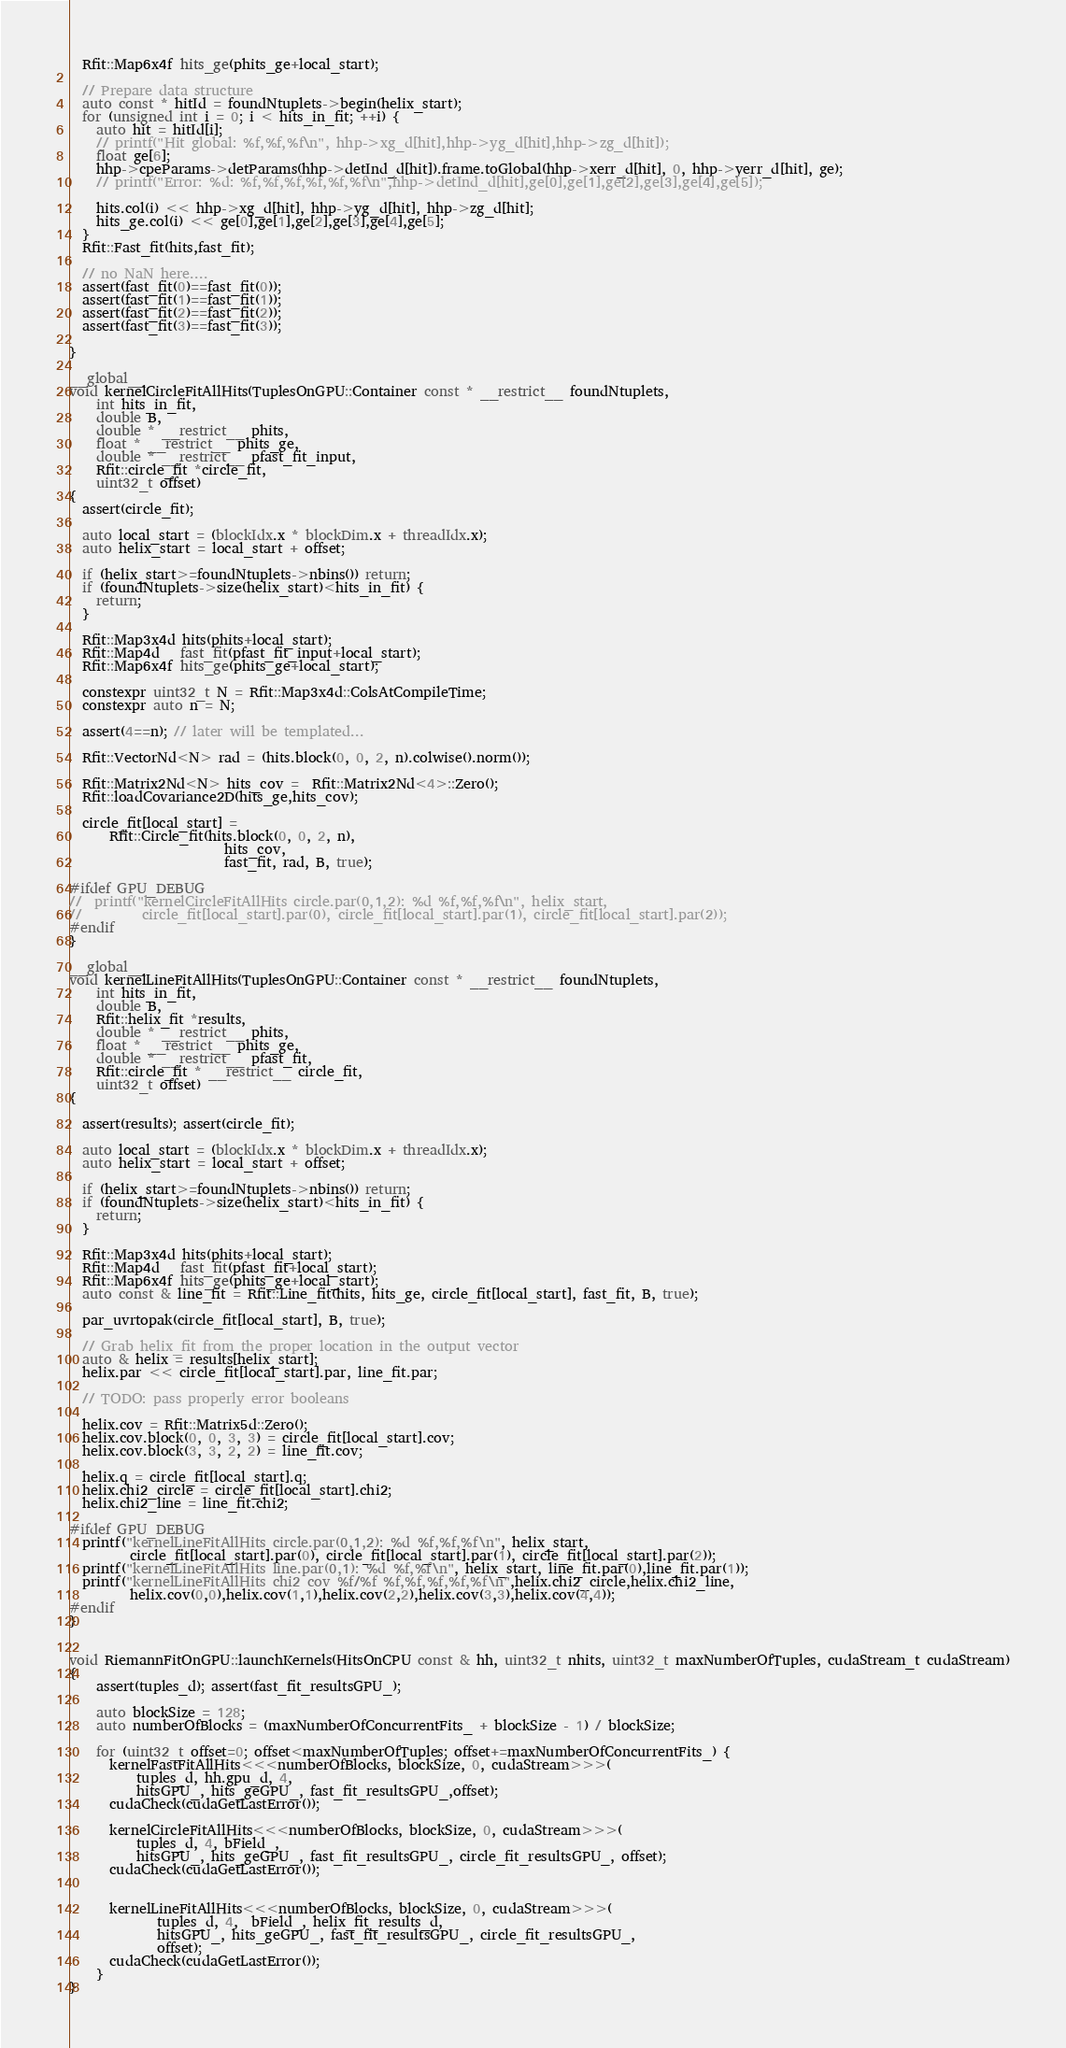Convert code to text. <code><loc_0><loc_0><loc_500><loc_500><_Cuda_>  Rfit::Map6x4f hits_ge(phits_ge+local_start);

  // Prepare data structure
  auto const * hitId = foundNtuplets->begin(helix_start);
  for (unsigned int i = 0; i < hits_in_fit; ++i) {
    auto hit = hitId[i];
    // printf("Hit global: %f,%f,%f\n", hhp->xg_d[hit],hhp->yg_d[hit],hhp->zg_d[hit]);
    float ge[6];
    hhp->cpeParams->detParams(hhp->detInd_d[hit]).frame.toGlobal(hhp->xerr_d[hit], 0, hhp->yerr_d[hit], ge);
    // printf("Error: %d: %f,%f,%f,%f,%f,%f\n",hhp->detInd_d[hit],ge[0],ge[1],ge[2],ge[3],ge[4],ge[5]);

    hits.col(i) << hhp->xg_d[hit], hhp->yg_d[hit], hhp->zg_d[hit];
    hits_ge.col(i) << ge[0],ge[1],ge[2],ge[3],ge[4],ge[5];
  }
  Rfit::Fast_fit(hits,fast_fit);

  // no NaN here....
  assert(fast_fit(0)==fast_fit(0));
  assert(fast_fit(1)==fast_fit(1));
  assert(fast_fit(2)==fast_fit(2));
  assert(fast_fit(3)==fast_fit(3));

}

__global__
void kernelCircleFitAllHits(TuplesOnGPU::Container const * __restrict__ foundNtuplets,
    int hits_in_fit,
    double B,
    double * __restrict__ phits,
    float * __restrict__ phits_ge,
    double * __restrict__ pfast_fit_input,
    Rfit::circle_fit *circle_fit,
    uint32_t offset)
{
  assert(circle_fit); 

  auto local_start = (blockIdx.x * blockDim.x + threadIdx.x);
  auto helix_start = local_start + offset;

  if (helix_start>=foundNtuplets->nbins()) return;
  if (foundNtuplets->size(helix_start)<hits_in_fit) {
    return;
  }

  Rfit::Map3x4d hits(phits+local_start);
  Rfit::Map4d   fast_fit(pfast_fit_input+local_start);
  Rfit::Map6x4f hits_ge(phits_ge+local_start);

  constexpr uint32_t N = Rfit::Map3x4d::ColsAtCompileTime;
  constexpr auto n = N;

  assert(4==n); // later will be templated...

  Rfit::VectorNd<N> rad = (hits.block(0, 0, 2, n).colwise().norm());

  Rfit::Matrix2Nd<N> hits_cov =  Rfit::Matrix2Nd<4>::Zero();
  Rfit::loadCovariance2D(hits_ge,hits_cov);

  circle_fit[local_start] =
      Rfit::Circle_fit(hits.block(0, 0, 2, n),
                       hits_cov,
                       fast_fit, rad, B, true);

#ifdef GPU_DEBUG
//  printf("kernelCircleFitAllHits circle.par(0,1,2): %d %f,%f,%f\n", helix_start, 
//         circle_fit[local_start].par(0), circle_fit[local_start].par(1), circle_fit[local_start].par(2));
#endif
}

__global__
void kernelLineFitAllHits(TuplesOnGPU::Container const * __restrict__ foundNtuplets,
    int hits_in_fit,
    double B,
    Rfit::helix_fit *results,
    double * __restrict__ phits,
    float * __restrict__ phits_ge,
    double * __restrict__ pfast_fit,
    Rfit::circle_fit * __restrict__ circle_fit,
    uint32_t offset)
{

  assert(results); assert(circle_fit);

  auto local_start = (blockIdx.x * blockDim.x + threadIdx.x);
  auto helix_start = local_start + offset;

  if (helix_start>=foundNtuplets->nbins()) return;
  if (foundNtuplets->size(helix_start)<hits_in_fit) {
    return;
  }

  Rfit::Map3x4d hits(phits+local_start);
  Rfit::Map4d   fast_fit(pfast_fit+local_start);
  Rfit::Map6x4f hits_ge(phits_ge+local_start);
  auto const & line_fit = Rfit::Line_fit(hits, hits_ge, circle_fit[local_start], fast_fit, B, true);

  par_uvrtopak(circle_fit[local_start], B, true);

  // Grab helix_fit from the proper location in the output vector
  auto & helix = results[helix_start];
  helix.par << circle_fit[local_start].par, line_fit.par;

  // TODO: pass properly error booleans

  helix.cov = Rfit::Matrix5d::Zero();
  helix.cov.block(0, 0, 3, 3) = circle_fit[local_start].cov;
  helix.cov.block(3, 3, 2, 2) = line_fit.cov;

  helix.q = circle_fit[local_start].q;
  helix.chi2_circle = circle_fit[local_start].chi2;
  helix.chi2_line = line_fit.chi2;

#ifdef GPU_DEBUG
  printf("kernelLineFitAllHits circle.par(0,1,2): %d %f,%f,%f\n", helix_start,
         circle_fit[local_start].par(0), circle_fit[local_start].par(1), circle_fit[local_start].par(2));
  printf("kernelLineFitAllHits line.par(0,1): %d %f,%f\n", helix_start, line_fit.par(0),line_fit.par(1));
  printf("kernelLineFitAllHits chi2 cov %f/%f %f,%f,%f,%f,%f\n",helix.chi2_circle,helix.chi2_line, 
         helix.cov(0,0),helix.cov(1,1),helix.cov(2,2),helix.cov(3,3),helix.cov(4,4));
#endif
}


void RiemannFitOnGPU::launchKernels(HitsOnCPU const & hh, uint32_t nhits, uint32_t maxNumberOfTuples, cudaStream_t cudaStream)
{
    assert(tuples_d); assert(fast_fit_resultsGPU_);

    auto blockSize = 128;
    auto numberOfBlocks = (maxNumberOfConcurrentFits_ + blockSize - 1) / blockSize;

    for (uint32_t offset=0; offset<maxNumberOfTuples; offset+=maxNumberOfConcurrentFits_) {
      kernelFastFitAllHits<<<numberOfBlocks, blockSize, 0, cudaStream>>>(
          tuples_d, hh.gpu_d, 4,
          hitsGPU_, hits_geGPU_, fast_fit_resultsGPU_,offset);
      cudaCheck(cudaGetLastError());

      kernelCircleFitAllHits<<<numberOfBlocks, blockSize, 0, cudaStream>>>(
          tuples_d, 4, bField_,
          hitsGPU_, hits_geGPU_, fast_fit_resultsGPU_, circle_fit_resultsGPU_, offset);
      cudaCheck(cudaGetLastError());


      kernelLineFitAllHits<<<numberOfBlocks, blockSize, 0, cudaStream>>>(
             tuples_d, 4,  bField_, helix_fit_results_d,
             hitsGPU_, hits_geGPU_, fast_fit_resultsGPU_, circle_fit_resultsGPU_,
             offset);
      cudaCheck(cudaGetLastError());
    }
}
</code> 